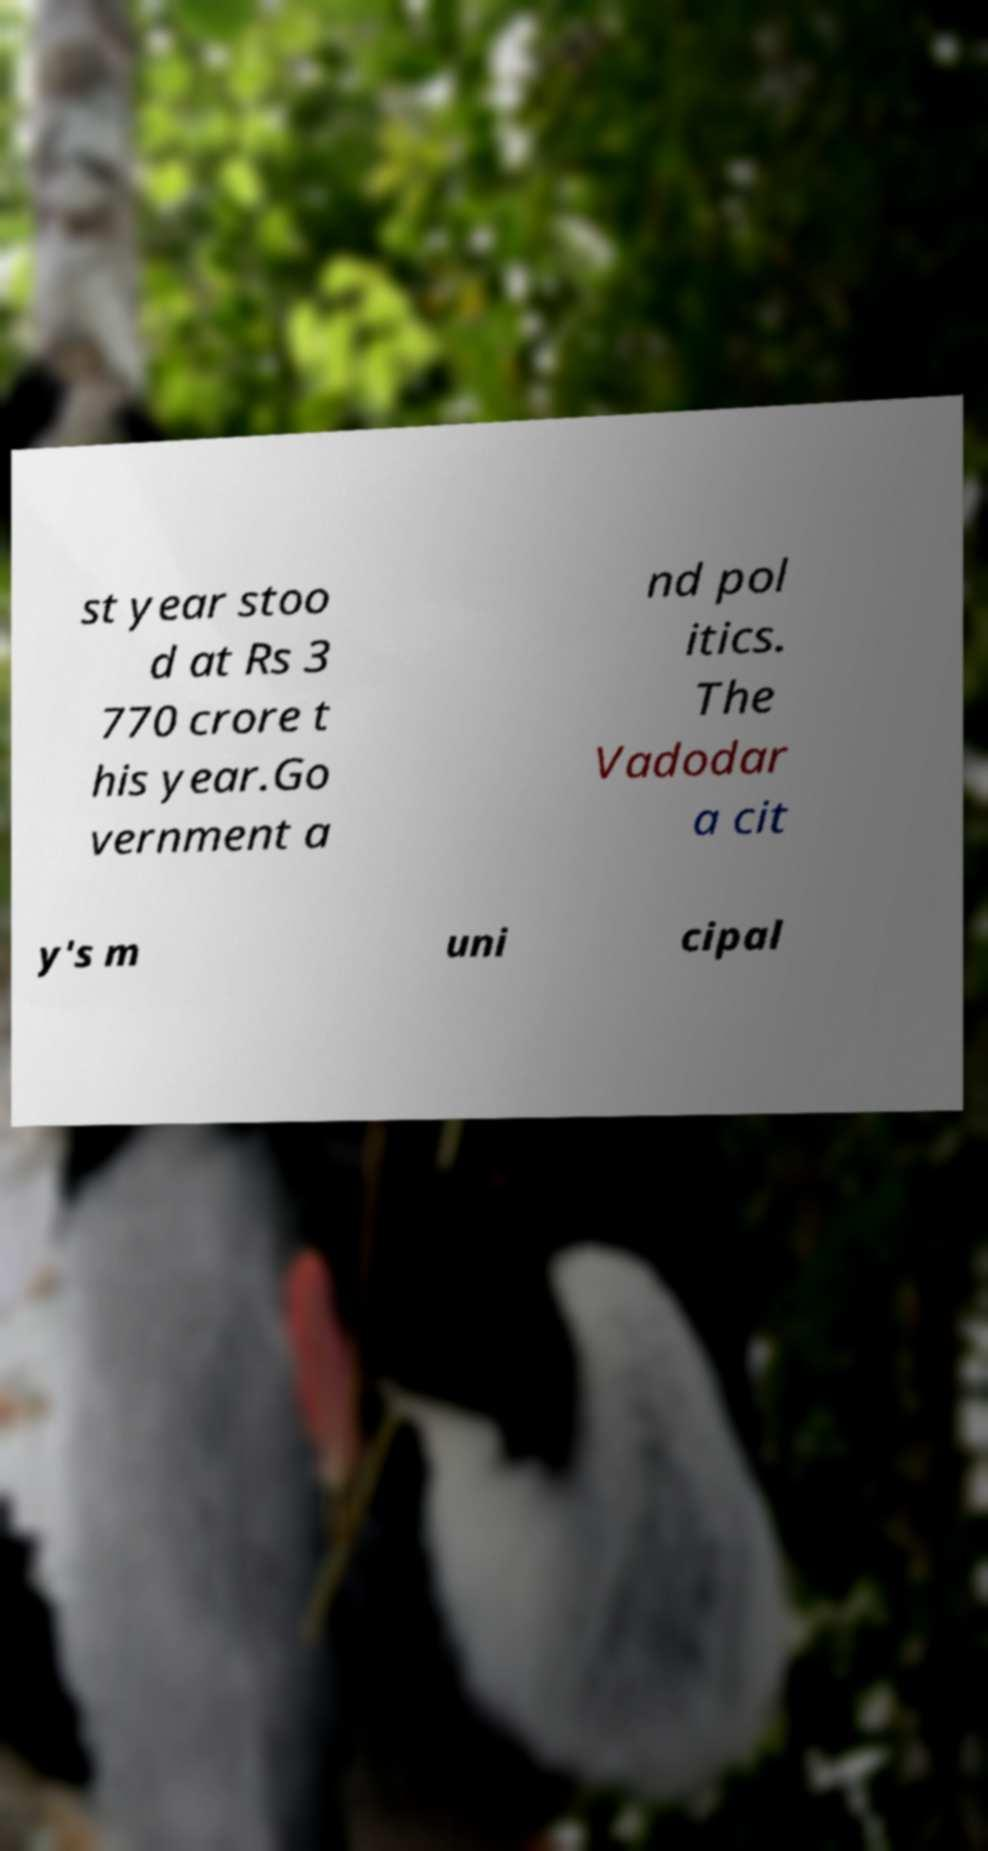Could you assist in decoding the text presented in this image and type it out clearly? st year stoo d at Rs 3 770 crore t his year.Go vernment a nd pol itics. The Vadodar a cit y's m uni cipal 